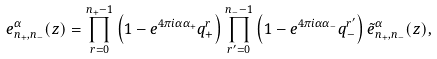<formula> <loc_0><loc_0><loc_500><loc_500>e ^ { \alpha } _ { n _ { + } , n _ { - } } ( z ) = \prod ^ { n _ { + } - 1 } _ { r = 0 } \left ( 1 - e ^ { 4 \pi i \alpha \alpha _ { + } } q ^ { r } _ { + } \right ) \prod ^ { n _ { - } - 1 } _ { r ^ { \prime } = 0 } \left ( 1 - e ^ { 4 \pi i \alpha \alpha _ { - } } q ^ { r ^ { \prime } } _ { - } \right ) \tilde { e } ^ { \alpha } _ { n _ { + } , n _ { - } } ( z ) ,</formula> 